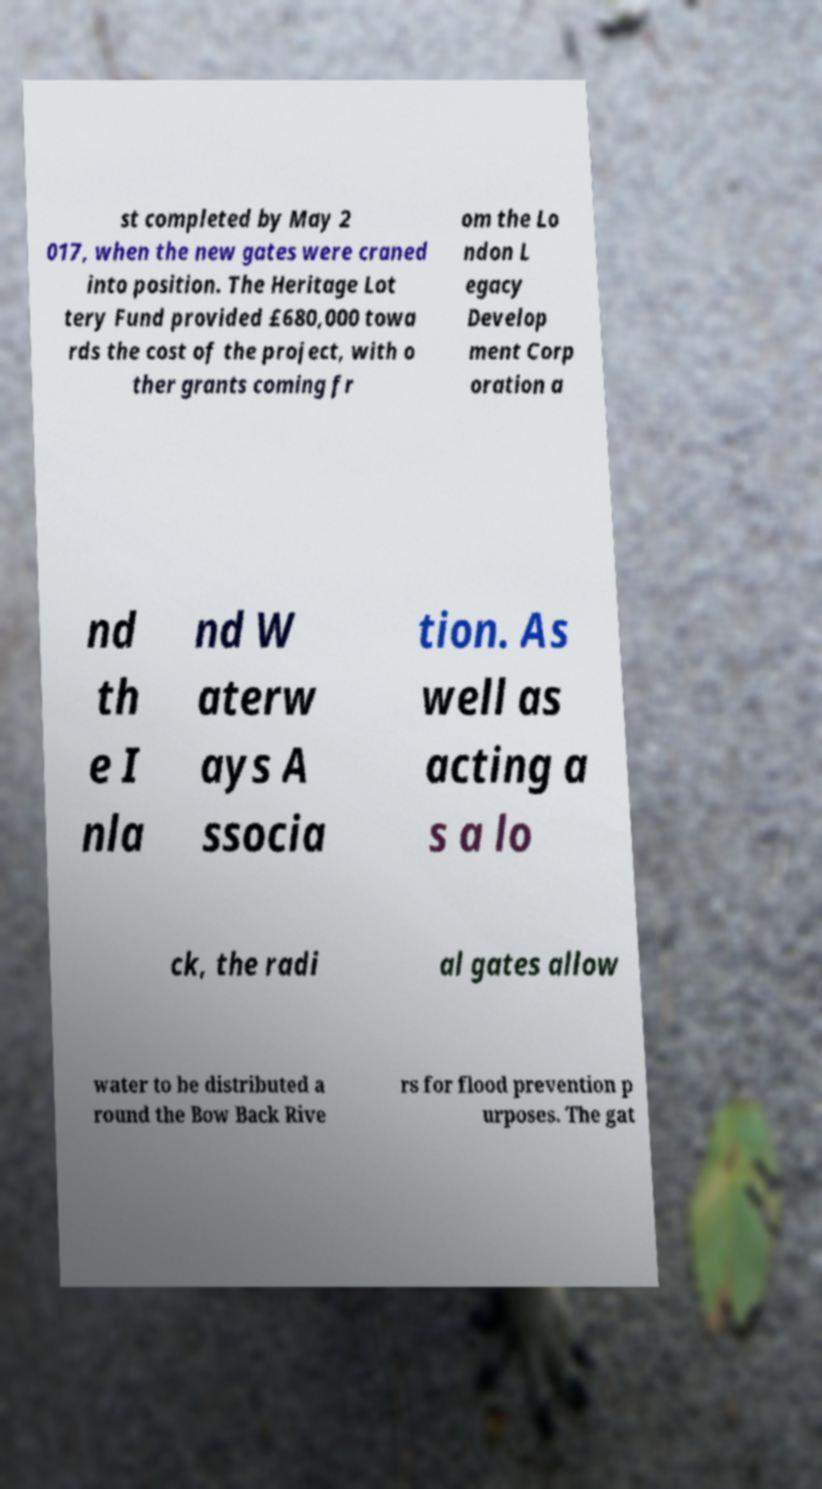Can you read and provide the text displayed in the image?This photo seems to have some interesting text. Can you extract and type it out for me? st completed by May 2 017, when the new gates were craned into position. The Heritage Lot tery Fund provided £680,000 towa rds the cost of the project, with o ther grants coming fr om the Lo ndon L egacy Develop ment Corp oration a nd th e I nla nd W aterw ays A ssocia tion. As well as acting a s a lo ck, the radi al gates allow water to be distributed a round the Bow Back Rive rs for flood prevention p urposes. The gat 